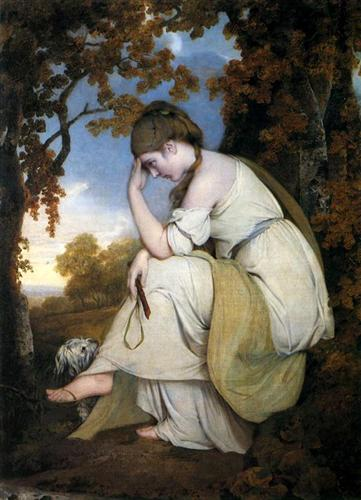Create a short poem inspired by this painting. In twilight's gentle, golden hue,
A maiden lost in thoughts anew,
Among the trees, in silence deep,
Nature seems to watch her weep. 